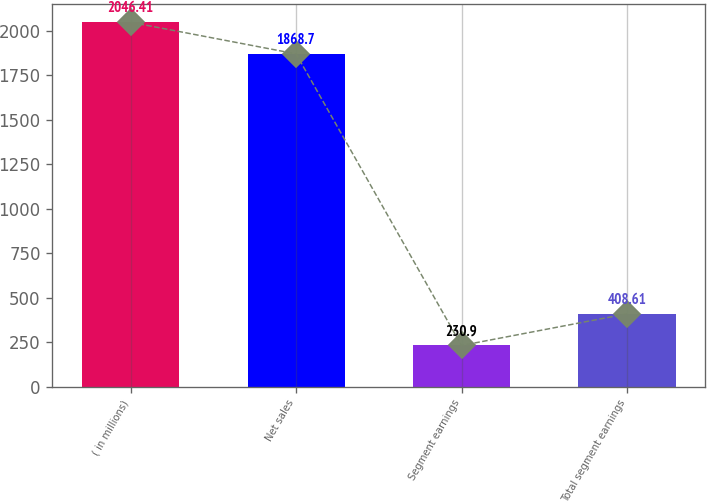<chart> <loc_0><loc_0><loc_500><loc_500><bar_chart><fcel>( in millions)<fcel>Net sales<fcel>Segment earnings<fcel>Total segment earnings<nl><fcel>2046.41<fcel>1868.7<fcel>230.9<fcel>408.61<nl></chart> 